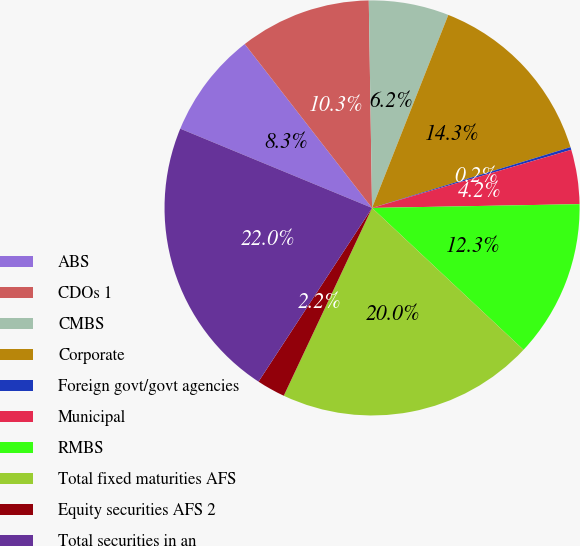Convert chart to OTSL. <chart><loc_0><loc_0><loc_500><loc_500><pie_chart><fcel>ABS<fcel>CDOs 1<fcel>CMBS<fcel>Corporate<fcel>Foreign govt/govt agencies<fcel>Municipal<fcel>RMBS<fcel>Total fixed maturities AFS<fcel>Equity securities AFS 2<fcel>Total securities in an<nl><fcel>8.25%<fcel>10.26%<fcel>6.24%<fcel>14.28%<fcel>0.21%<fcel>4.23%<fcel>12.27%<fcel>20.01%<fcel>2.22%<fcel>22.02%<nl></chart> 